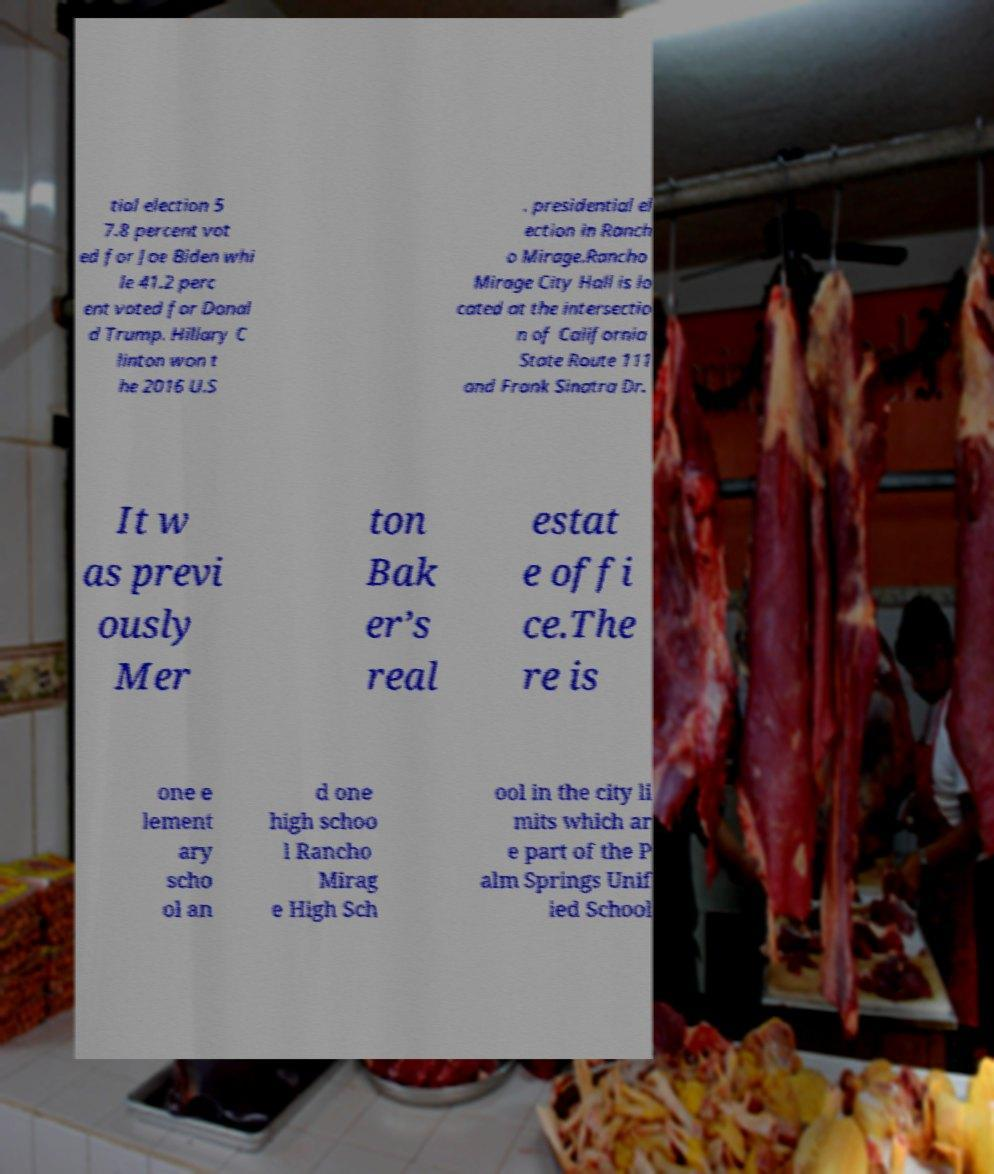There's text embedded in this image that I need extracted. Can you transcribe it verbatim? tial election 5 7.8 percent vot ed for Joe Biden whi le 41.2 perc ent voted for Donal d Trump. Hillary C linton won t he 2016 U.S . presidential el ection in Ranch o Mirage.Rancho Mirage City Hall is lo cated at the intersectio n of California State Route 111 and Frank Sinatra Dr. It w as previ ously Mer ton Bak er’s real estat e offi ce.The re is one e lement ary scho ol an d one high schoo l Rancho Mirag e High Sch ool in the city li mits which ar e part of the P alm Springs Unif ied School 